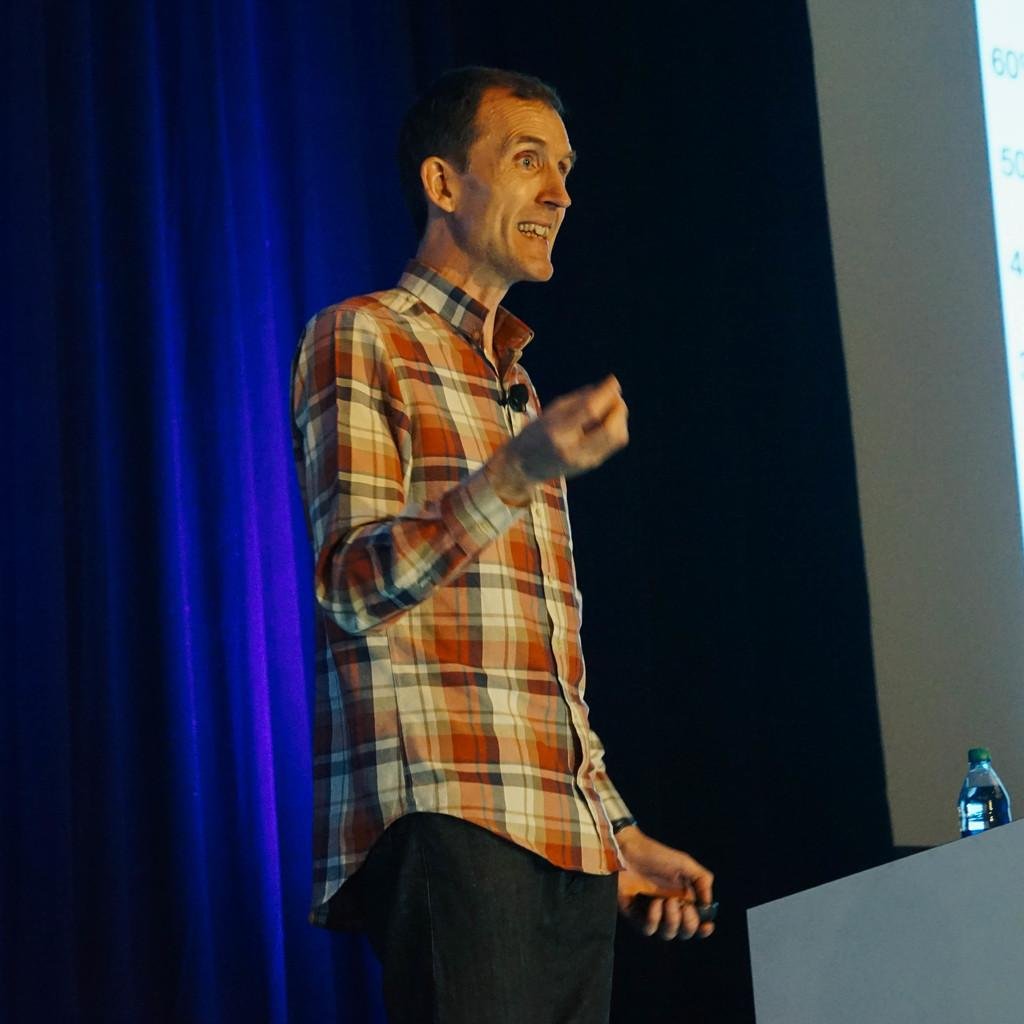What is the man in the image doing? The man is standing in the image. What object is the man holding in his hand? The man is holding a remote in his hand. What can be seen on the table in the image? There is a water bottle on a table in the image. What type of window treatment is visible in the image? There is a curtain visible in the image. What type of toy can be seen supporting the water bottle in the image? There is no toy present in the image, and the water bottle is not being supported by any object. 